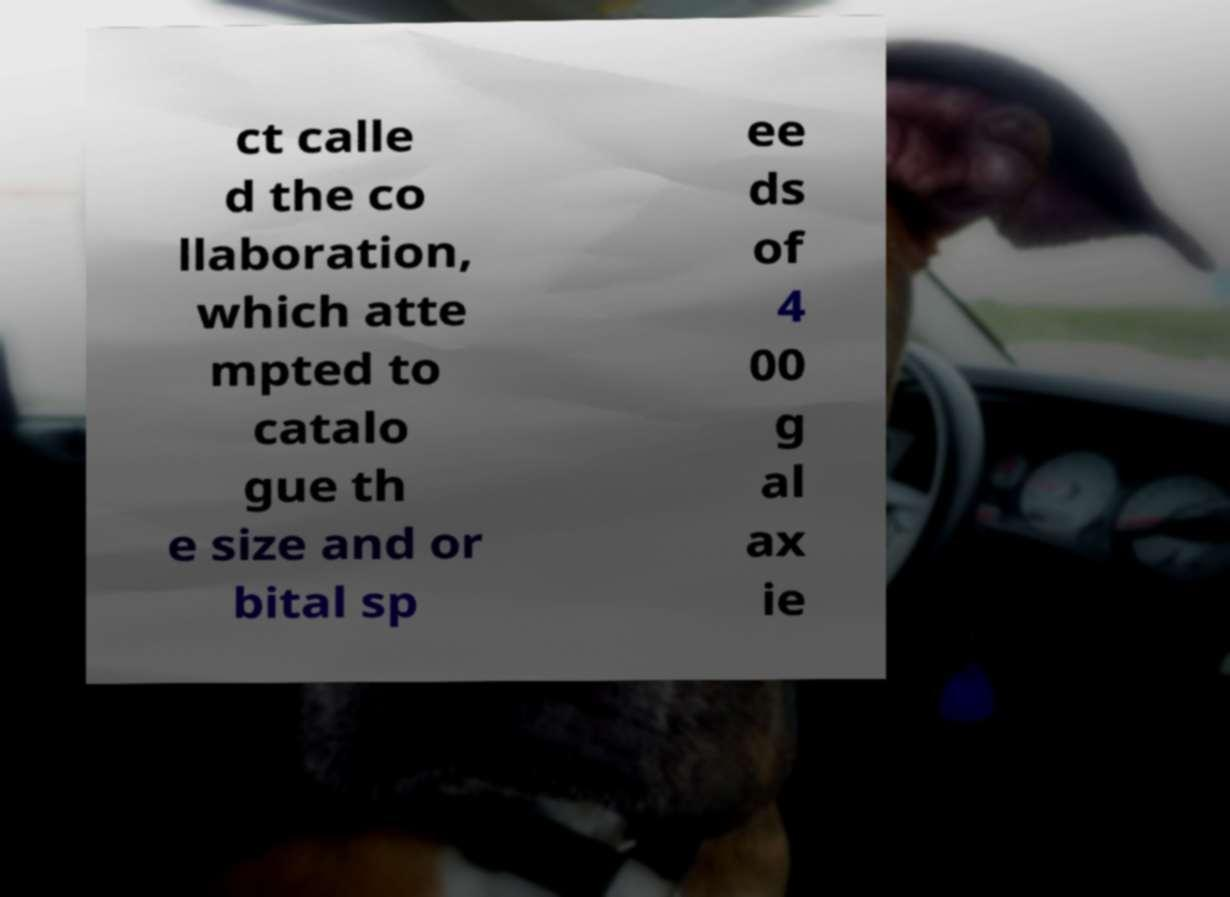Could you extract and type out the text from this image? ct calle d the co llaboration, which atte mpted to catalo gue th e size and or bital sp ee ds of 4 00 g al ax ie 